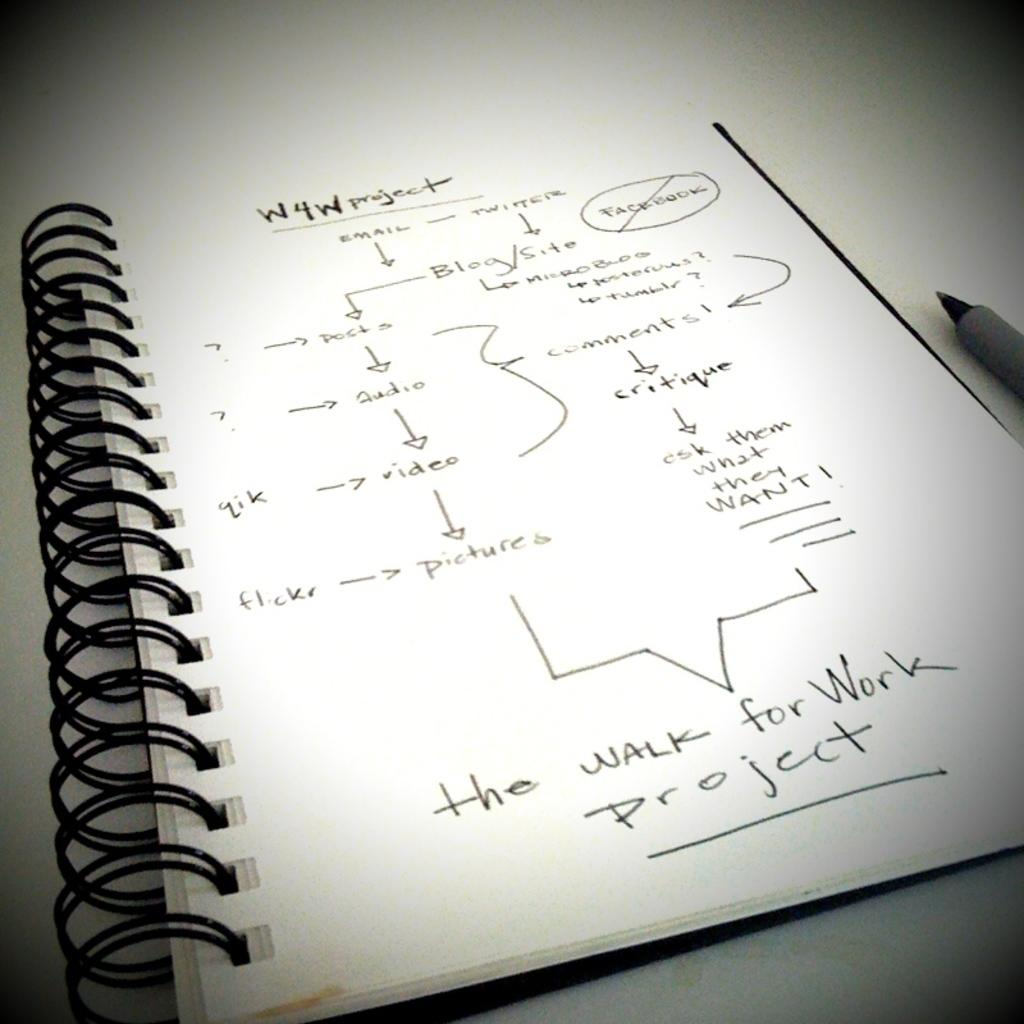<image>
Render a clear and concise summary of the photo. A page with handwriting on it is titled W4W project. 